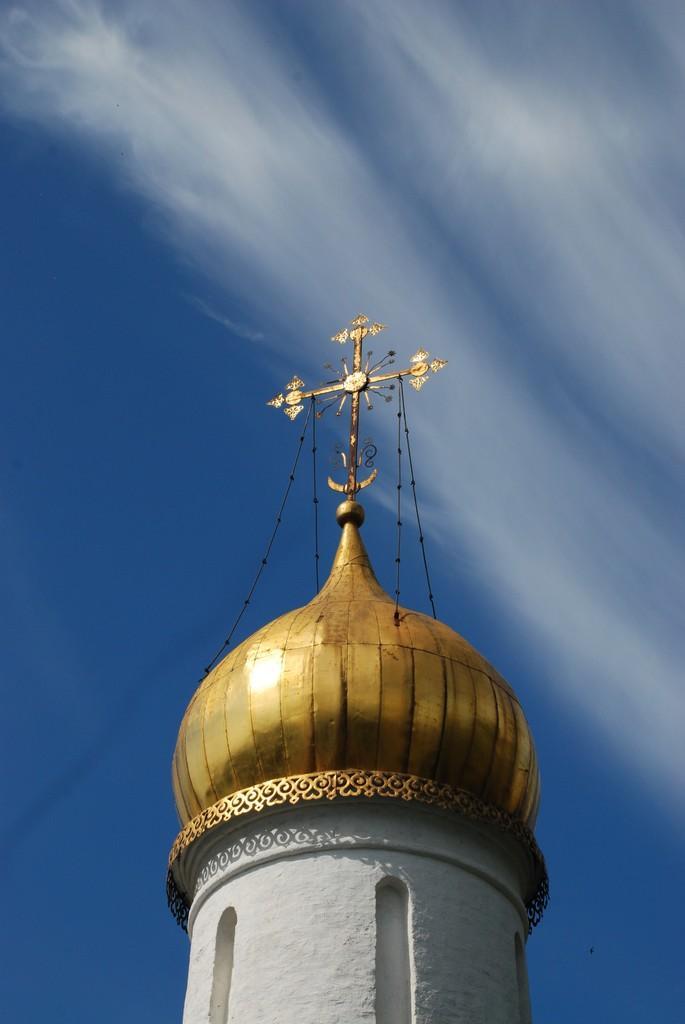Describe this image in one or two sentences. In this picture I can see a dome in the middle, in the background there is the sky. 